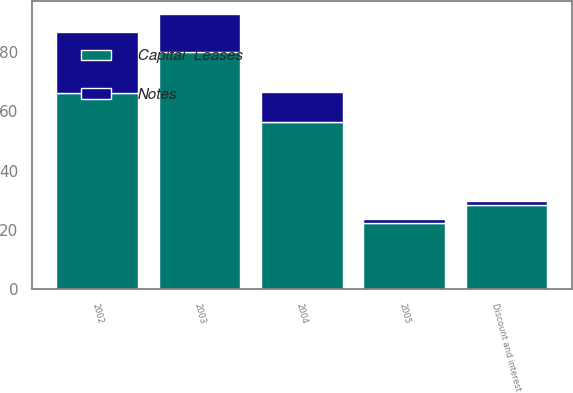Convert chart. <chart><loc_0><loc_0><loc_500><loc_500><stacked_bar_chart><ecel><fcel>2002<fcel>2003<fcel>2004<fcel>2005<fcel>Discount and interest<nl><fcel>Capital  Leases<fcel>66.3<fcel>80<fcel>56.4<fcel>22.3<fcel>28.3<nl><fcel>Notes<fcel>20.6<fcel>12.7<fcel>10.2<fcel>1.6<fcel>1.4<nl></chart> 